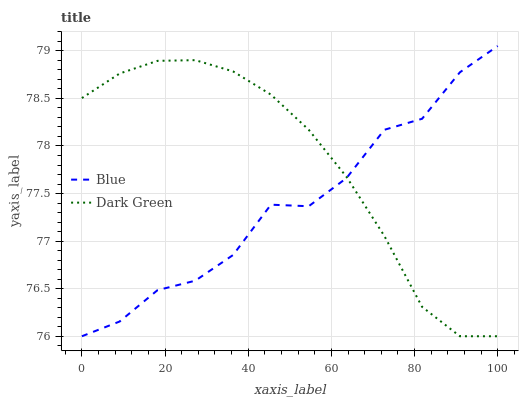Does Blue have the minimum area under the curve?
Answer yes or no. Yes. Does Dark Green have the maximum area under the curve?
Answer yes or no. Yes. Does Dark Green have the minimum area under the curve?
Answer yes or no. No. Is Dark Green the smoothest?
Answer yes or no. Yes. Is Blue the roughest?
Answer yes or no. Yes. Is Dark Green the roughest?
Answer yes or no. No. Does Blue have the highest value?
Answer yes or no. Yes. Does Dark Green have the highest value?
Answer yes or no. No. 